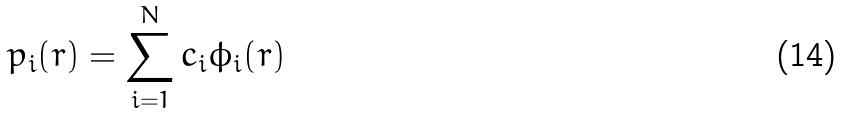<formula> <loc_0><loc_0><loc_500><loc_500>p _ { i } ( r ) = \sum _ { i = 1 } ^ { N } c _ { i } \phi _ { i } ( r )</formula> 